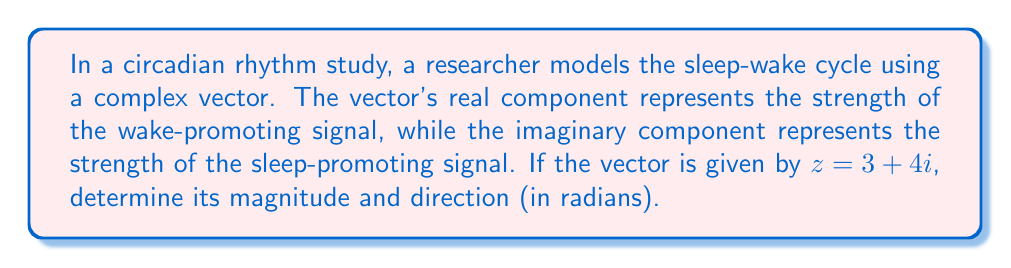Provide a solution to this math problem. To solve this problem, we need to calculate the magnitude and direction of the complex vector $z = 3 + 4i$.

1. Magnitude calculation:
   The magnitude of a complex number $z = a + bi$ is given by the formula:
   $$|z| = \sqrt{a^2 + b^2}$$
   
   In this case, $a = 3$ and $b = 4$. So:
   $$|z| = \sqrt{3^2 + 4^2} = \sqrt{9 + 16} = \sqrt{25} = 5$$

2. Direction calculation:
   The direction (or argument) of a complex number is given by the formula:
   $$\arg(z) = \tan^{-1}\left(\frac{b}{a}\right)$$
   
   Here, $\frac{b}{a} = \frac{4}{3}$. So:
   $$\arg(z) = \tan^{-1}\left(\frac{4}{3}\right) \approx 0.9273 \text{ radians}$$

Therefore, the magnitude of the vector is 5, representing the overall strength of the combined wake-promoting and sleep-promoting signals. The direction is approximately 0.9273 radians, indicating the balance between these two signals in the sleep-wake cycle model.
Answer: Magnitude: 5, Direction: 0.9273 radians 